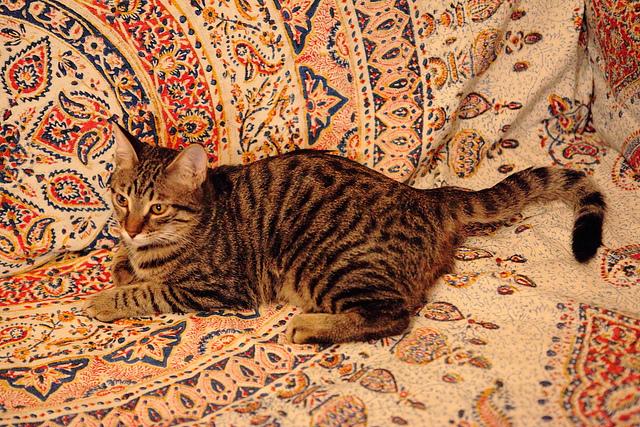What color is the cat?
Be succinct. Brown and black. Are the cat's eyes open?
Answer briefly. Yes. How many rings are on the cat's tail?
Short answer required. 9. What is the cat laying on?
Answer briefly. Blanket. 